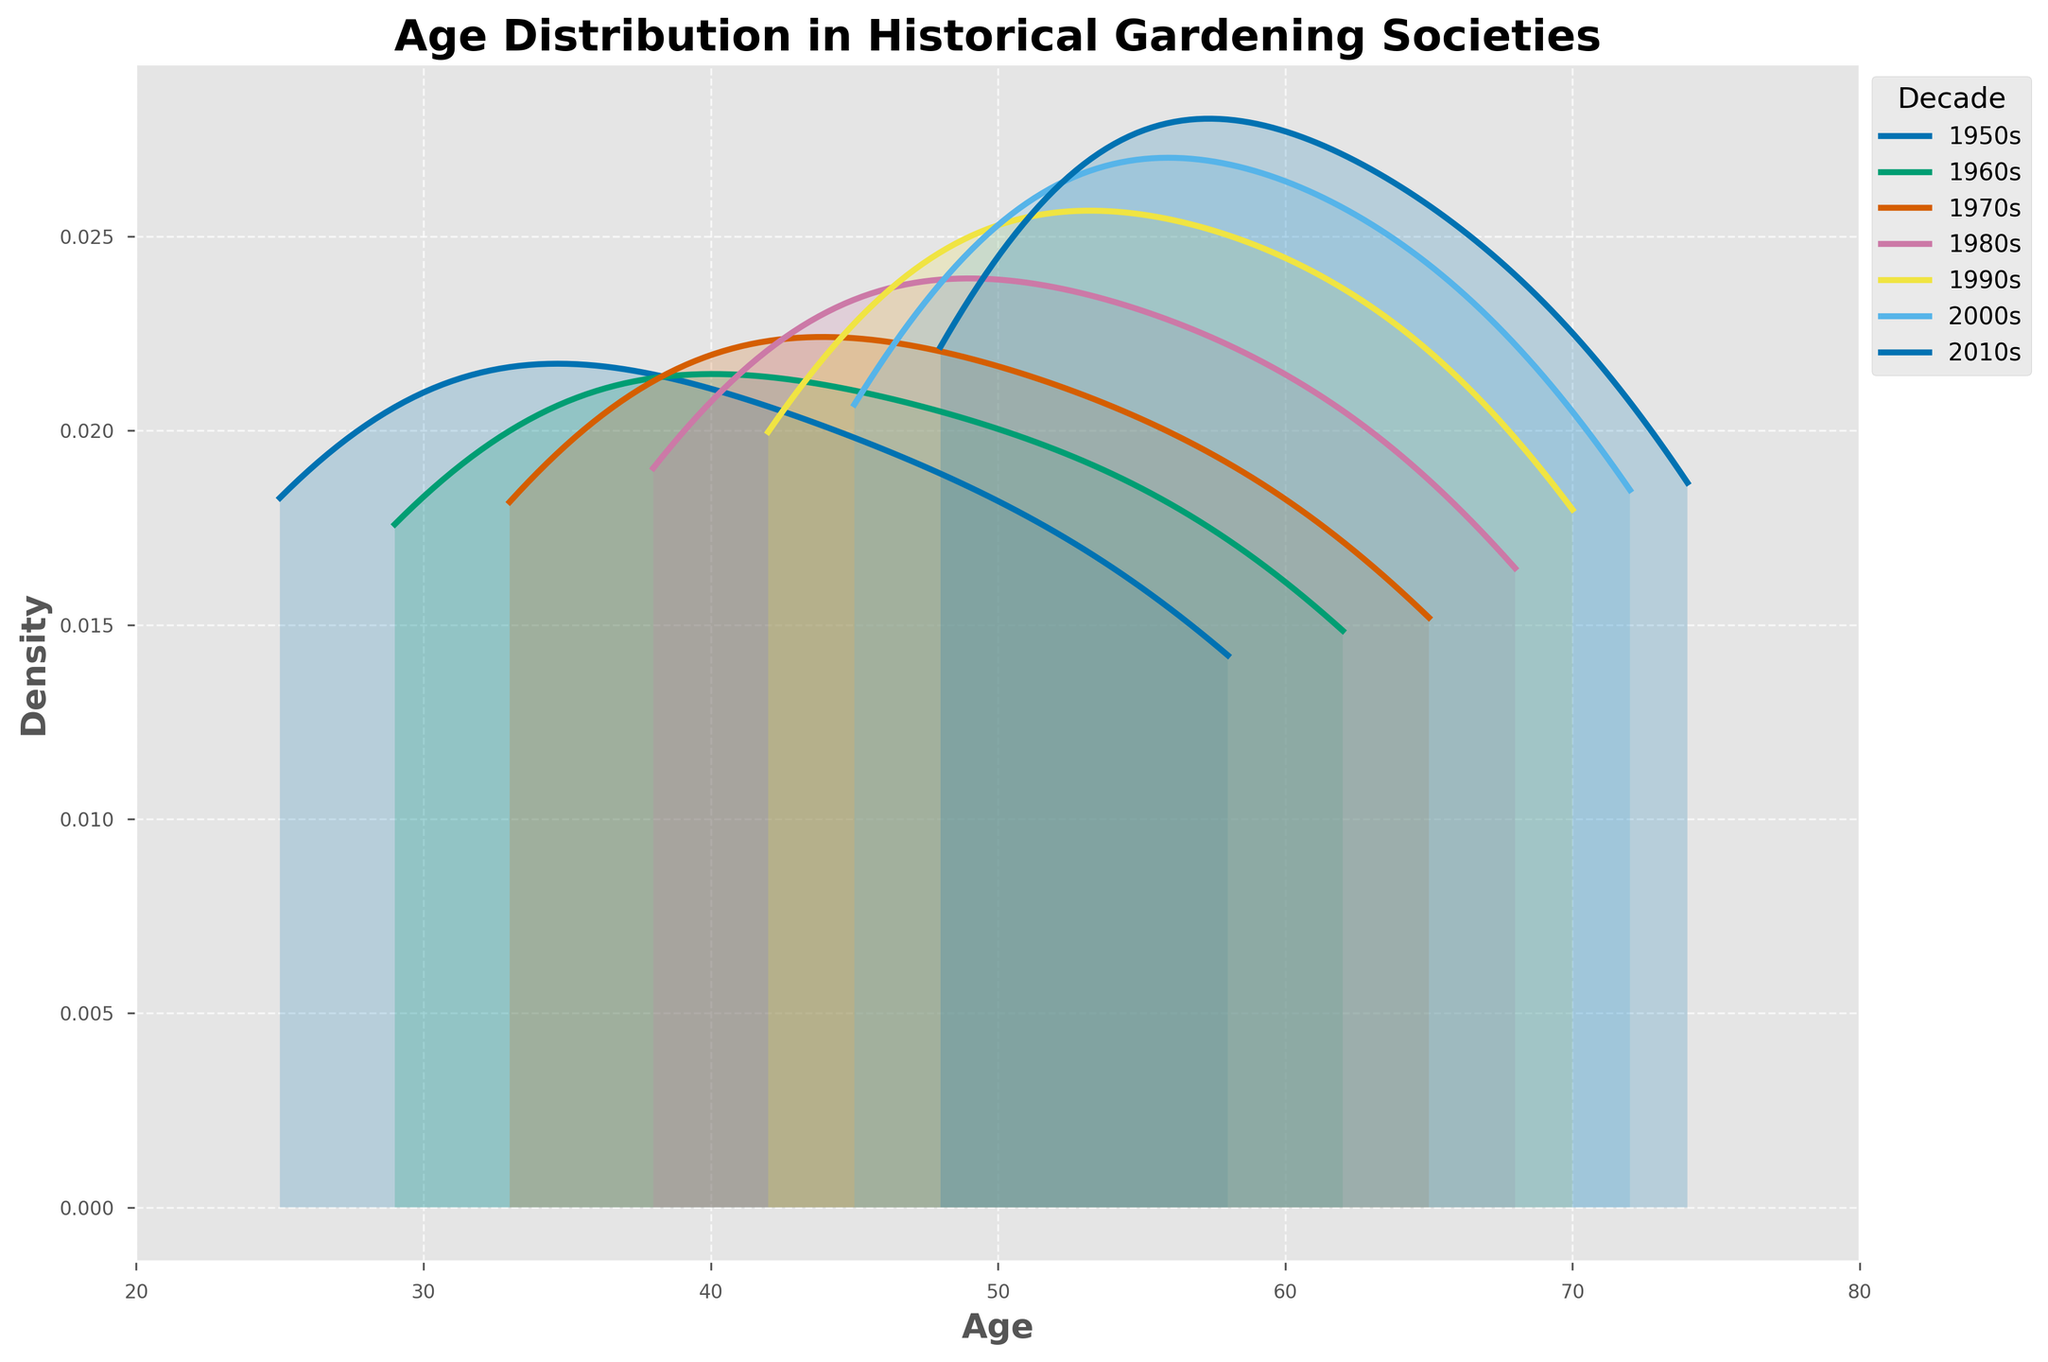What does the title of the figure say? The title is located at the top of the figure, and it provides an overview of what the plot is about. By looking at the title, one can see it describes the age distribution in historical gardening societies.
Answer: "Age Distribution in Historical Gardening Societies" What are the x-axis and y-axis labels? The x-axis and y-axis labels give context to what each axis represents in the plot. Looking at the plot, the x-axis is labeled 'Age' and the y-axis is labeled 'Density'.
Answer: 'Age' and 'Density' Which decade appears to have the youngest age distribution peak? Identify the peak (highest point) on each density curve and compare their positions along the x-axis. The curve with the peak furthest to the left represents the youngest age distribution. Based on the curves, the 1950s have the peak furthest to the left.
Answer: 1950s How do the age distributions of the 1950s and 2010s compare in terms of spread and central tendency? Look at the density curves for both the 1950s and 2010s. The spread is wider if the curve is more dispersed along the x-axis. The central tendency can be inferred from the position of the peak. The 2010s have a wider spread and a peak at an older age compared to the 1950s, which has a more concentrated and younger peak.
Answer: The 1950s have a more concentrated and younger distribution, while the 2010s have a wider and older distribution What does the density plot indicate about the trend in age distribution from the 1950s to the 2010s? Observe the shift in the peaks of the density plots from left to right across the decades. The peaks gradually move from younger ages in the 1950s to older ages in the 2010s. This trend indicates that the average age of members in these societies has increased over decades.
Answer: There is an increasing trend in the average age of members over time Which decade has the highest age density around age 60? Look for the position of age 60 on the x-axis and observe which density curve has the highest value at this point. The plot shows that the density at age 60 is highest for the 1990s.
Answer: 1990s Is there a decade where a wide range of ages from 40 to 70 has relatively high density? Examine the range from 40 to 70 on the x-axis and observe the density curves within this range. The 2010s show a relatively high density across this broad range, indicating a more varied age distribution in this decade.
Answer: 2010s Compare the density distributions of the 1960s and 1980s. What are the differences in their peaks and spreads? Look at the density curves for the 1960s and 1980s. Observe the location and height of their peaks and how widely they are spread on the x-axis. The 1980s have a higher peak and are slightly shifted to the right compared to the 1960s, which have a lower and broader peak.
Answer: 1980s have a higher peak and are more right-shifted than the 1960s Which decade has the least overlap with the 1950s density curve? Examine the degree of overlap between the density curves for each decade and the density curve for the 1950s. The decade with the smallest area of overlap with the 1950s is the 2010s, indicating a more distinct age distribution.
Answer: 2010s 